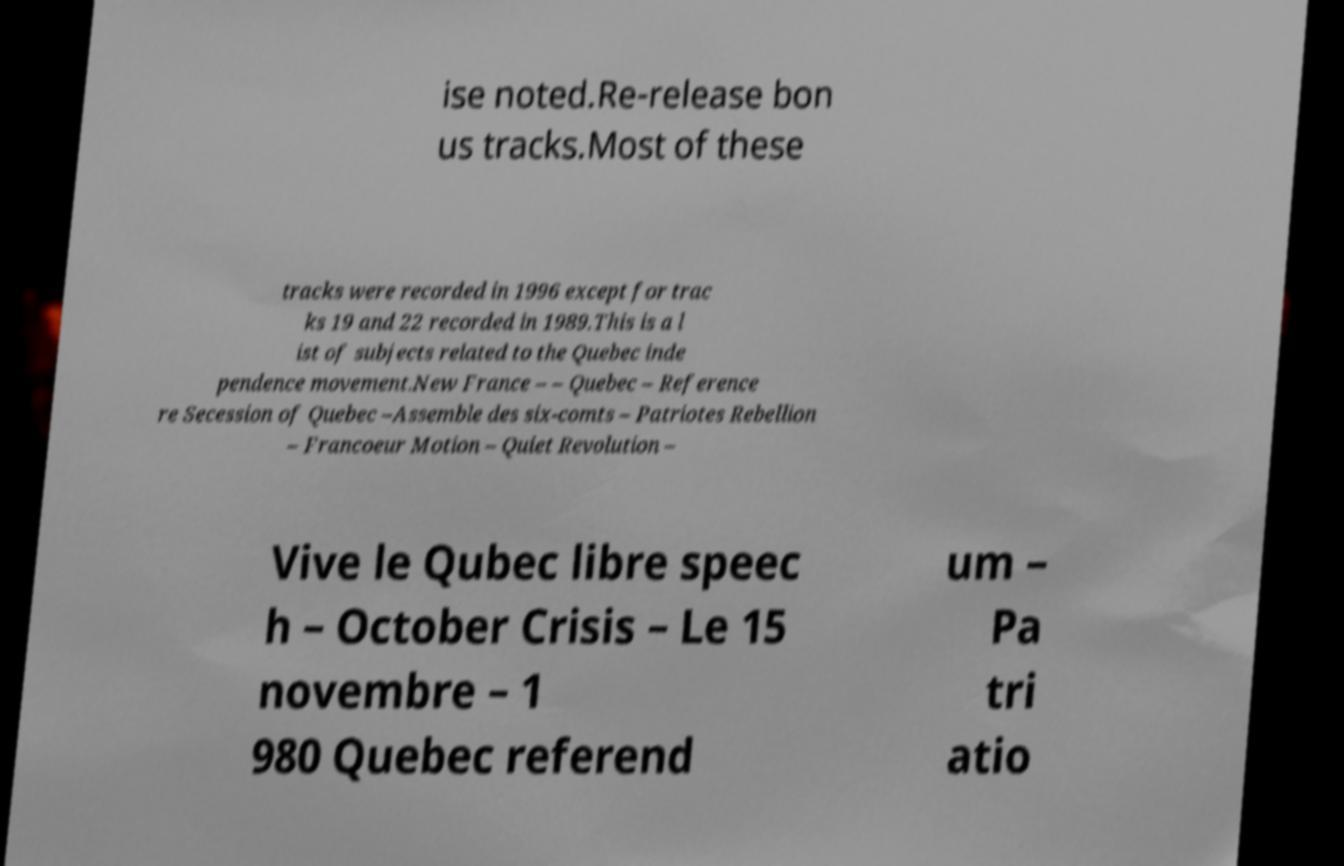What messages or text are displayed in this image? I need them in a readable, typed format. ise noted.Re-release bon us tracks.Most of these tracks were recorded in 1996 except for trac ks 19 and 22 recorded in 1989.This is a l ist of subjects related to the Quebec inde pendence movement.New France – – Quebec – Reference re Secession of Quebec –Assemble des six-comts – Patriotes Rebellion – Francoeur Motion – Quiet Revolution – Vive le Qubec libre speec h – October Crisis – Le 15 novembre – 1 980 Quebec referend um – Pa tri atio 